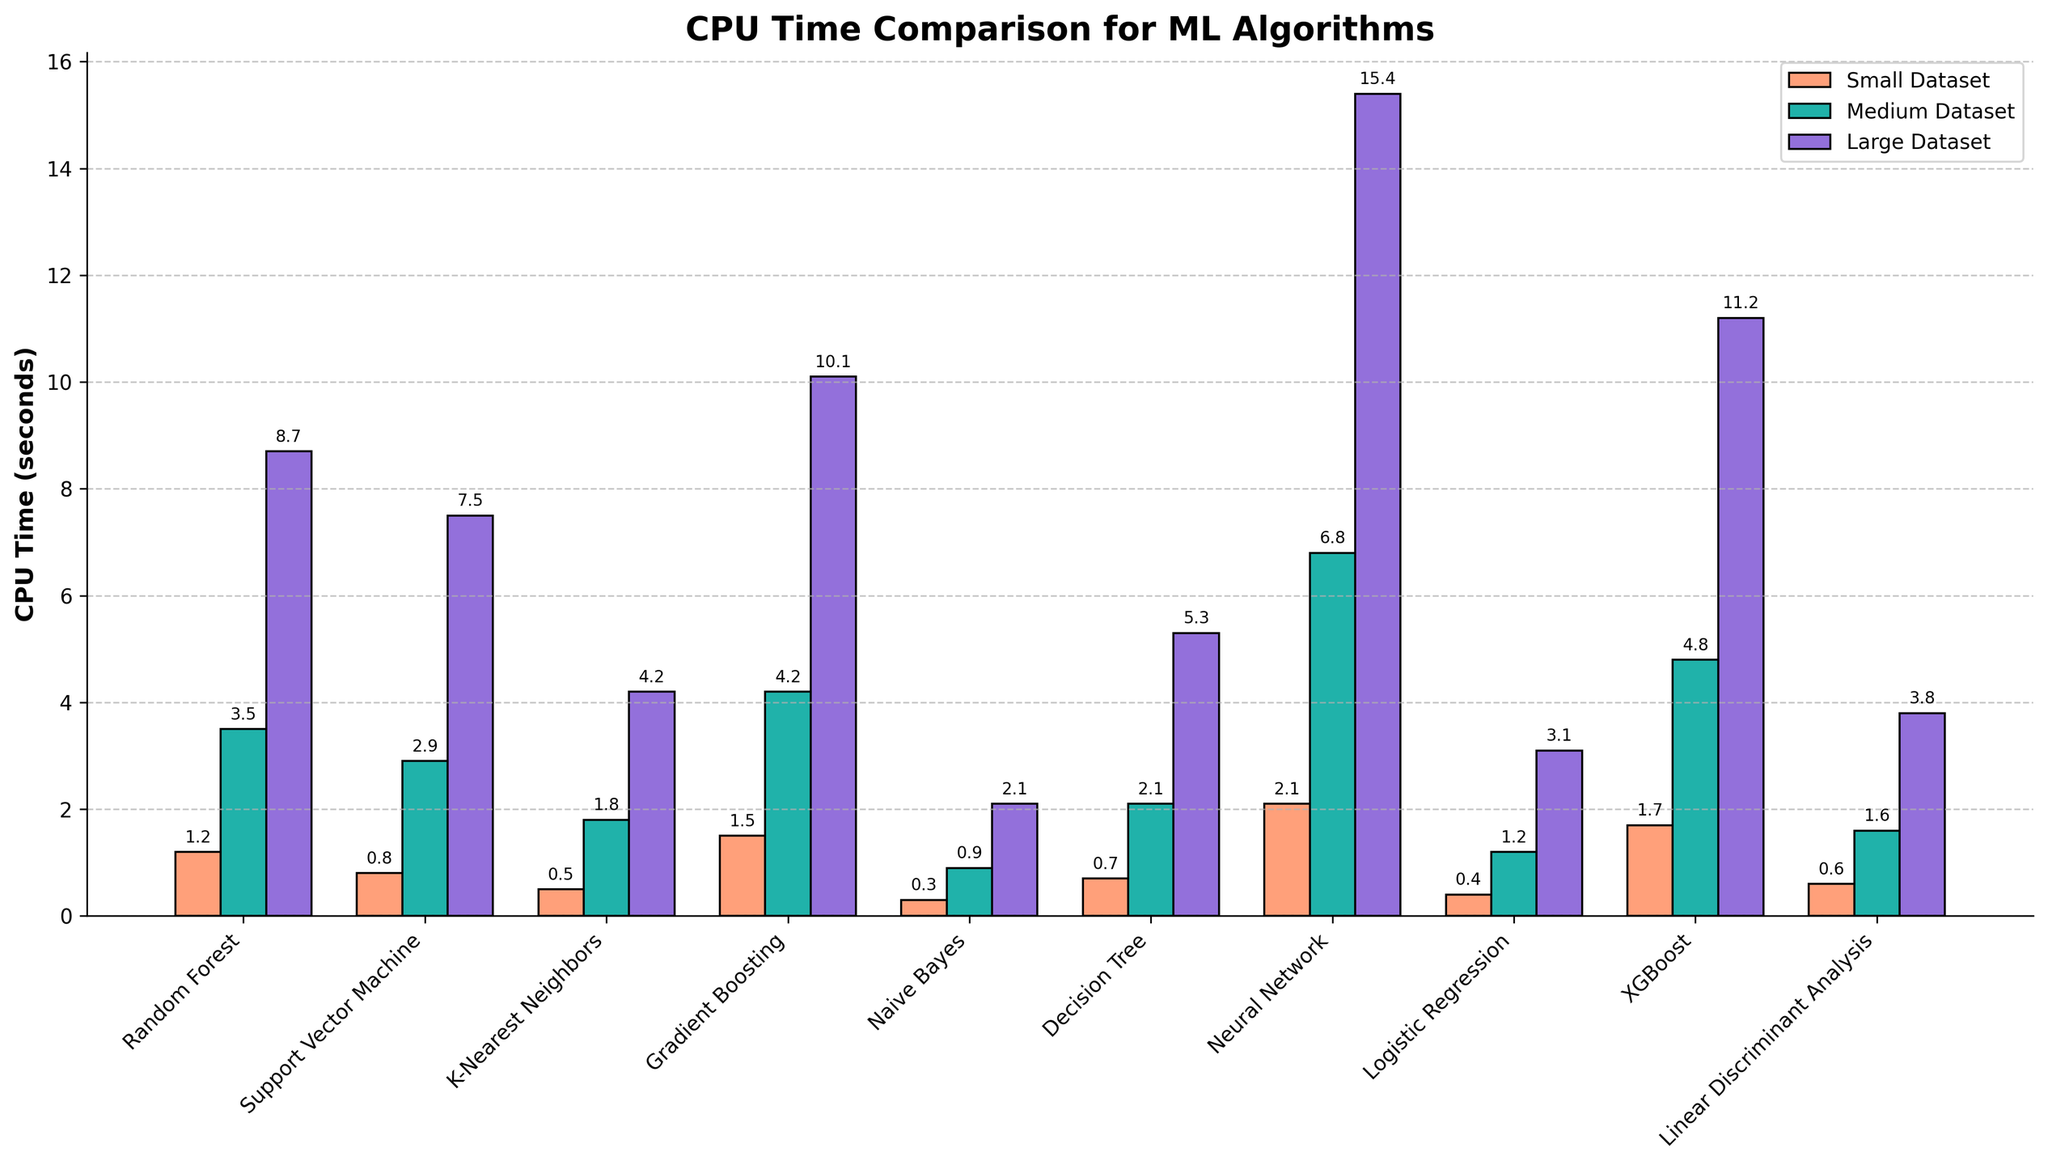Which algorithm has the highest CPU time for a large dataset? The bar representing Neural Network for the large dataset is the tallest, indicating that it has the highest CPU time compared to other algorithms.
Answer: Neural Network What is the difference in CPU time for Naive Bayes between the small and large datasets? The CPU time for Naive Bayes on small and large datasets are 0.3 and 2.1 seconds respectively. The difference is calculated as 2.1 - 0.3.
Answer: 1.8 seconds Which dataset size results in the smallest CPU time for Logistic Regression? The shortest bar for Logistic Regression is for the small dataset.
Answer: Small Dataset How does the CPU time of Gradient Boosting on a medium dataset compare to that on a large dataset? The bar for Gradient Boosting on the medium dataset is shorter than the one on the large dataset. The corresponding CPU times are 4.2 and 10.1 seconds, respectively.
Answer: Less on the medium dataset What is the average CPU time for Neural Network across all dataset sizes? The CPU times for Neural Network are 2.1 (small), 6.8 (medium), and 15.4 (large) seconds. The average is calculated as (2.1 + 6.8 + 15.4) / 3.
Answer: 8.1 seconds Among the algorithms, which one performs the quickest on a small dataset? The bar for Naive Bayes on the small dataset is the shortest, indicating that it has the quickest CPU time.
Answer: Naive Bayes Is the CPU time for XGBoost on a small dataset greater or less than that for a medium dataset of K-Nearest Neighbors? The CPU time for XGBoost on a small dataset is 1.7 seconds, while the CPU time for K-Nearest Neighbors on a medium dataset is 1.8 seconds.
Answer: Less What is the combined CPU time for Random Forest across all dataset sizes? The CPU times for Random Forest are 1.2 (small), 3.5 (medium), and 8.7 (large) seconds. The combined CPU time is calculated as 1.2 + 3.5 + 8.7.
Answer: 13.4 seconds Which algorithm shows the most significant increase in CPU time from a medium dataset to a large dataset? By comparing the differences in CPU times between medium and large datasets, Neural Network shows the most significant increase with 15.4 - 6.8 = 8.6 seconds.
Answer: Neural Network 